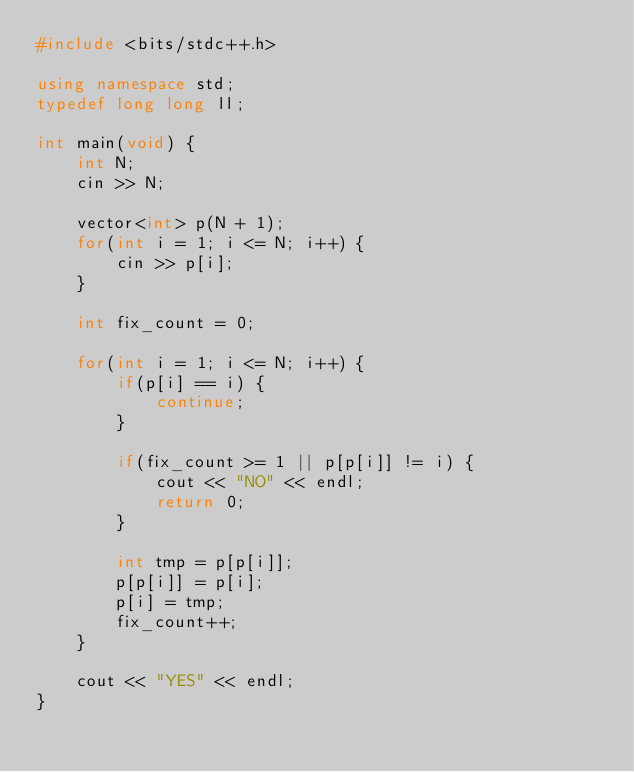<code> <loc_0><loc_0><loc_500><loc_500><_C++_>#include <bits/stdc++.h>

using namespace std;
typedef long long ll;

int main(void) {
    int N;
    cin >> N;

    vector<int> p(N + 1);
    for(int i = 1; i <= N; i++) {
        cin >> p[i];
    }

    int fix_count = 0;

    for(int i = 1; i <= N; i++) {
        if(p[i] == i) {
            continue;
        }

        if(fix_count >= 1 || p[p[i]] != i) {
            cout << "NO" << endl;
            return 0;
        }

        int tmp = p[p[i]];
        p[p[i]] = p[i];
        p[i] = tmp;
        fix_count++;
    }

    cout << "YES" << endl;
}</code> 